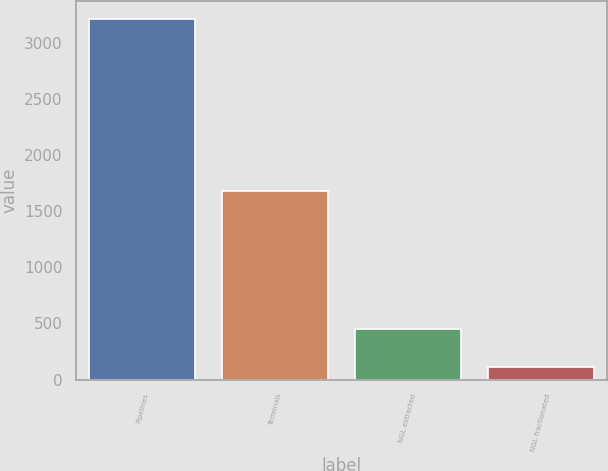<chart> <loc_0><loc_0><loc_500><loc_500><bar_chart><fcel>Pipelines<fcel>Terminals<fcel>NGL extracted<fcel>NGL fractionated<nl><fcel>3206<fcel>1683<fcel>454<fcel>109<nl></chart> 